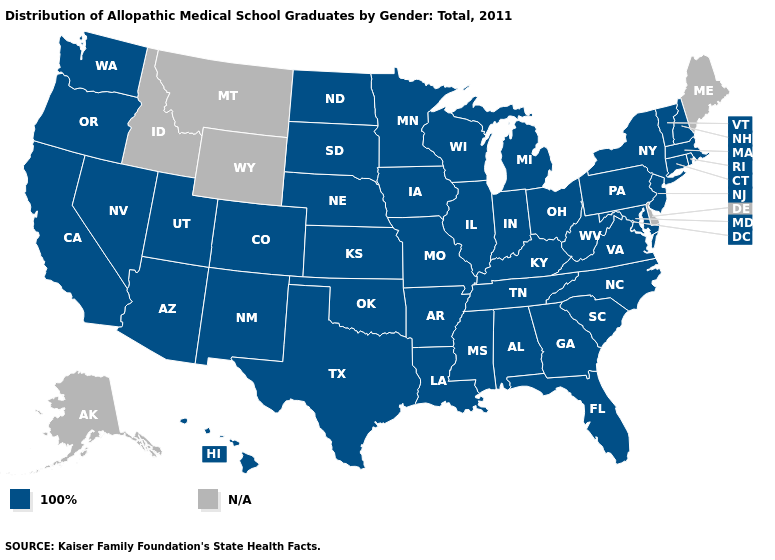Among the states that border Utah , which have the highest value?
Keep it brief. Arizona, Colorado, Nevada, New Mexico. What is the value of Nebraska?
Write a very short answer. 100%. Which states have the highest value in the USA?
Quick response, please. Alabama, Arizona, Arkansas, California, Colorado, Connecticut, Florida, Georgia, Hawaii, Illinois, Indiana, Iowa, Kansas, Kentucky, Louisiana, Maryland, Massachusetts, Michigan, Minnesota, Mississippi, Missouri, Nebraska, Nevada, New Hampshire, New Jersey, New Mexico, New York, North Carolina, North Dakota, Ohio, Oklahoma, Oregon, Pennsylvania, Rhode Island, South Carolina, South Dakota, Tennessee, Texas, Utah, Vermont, Virginia, Washington, West Virginia, Wisconsin. What is the value of Utah?
Answer briefly. 100%. Name the states that have a value in the range N/A?
Give a very brief answer. Alaska, Delaware, Idaho, Maine, Montana, Wyoming. Is the legend a continuous bar?
Answer briefly. No. Is the legend a continuous bar?
Answer briefly. No. Among the states that border South Dakota , which have the highest value?
Keep it brief. Iowa, Minnesota, Nebraska, North Dakota. Name the states that have a value in the range N/A?
Concise answer only. Alaska, Delaware, Idaho, Maine, Montana, Wyoming. Name the states that have a value in the range N/A?
Answer briefly. Alaska, Delaware, Idaho, Maine, Montana, Wyoming. Name the states that have a value in the range N/A?
Be succinct. Alaska, Delaware, Idaho, Maine, Montana, Wyoming. Name the states that have a value in the range 100%?
Concise answer only. Alabama, Arizona, Arkansas, California, Colorado, Connecticut, Florida, Georgia, Hawaii, Illinois, Indiana, Iowa, Kansas, Kentucky, Louisiana, Maryland, Massachusetts, Michigan, Minnesota, Mississippi, Missouri, Nebraska, Nevada, New Hampshire, New Jersey, New Mexico, New York, North Carolina, North Dakota, Ohio, Oklahoma, Oregon, Pennsylvania, Rhode Island, South Carolina, South Dakota, Tennessee, Texas, Utah, Vermont, Virginia, Washington, West Virginia, Wisconsin. 